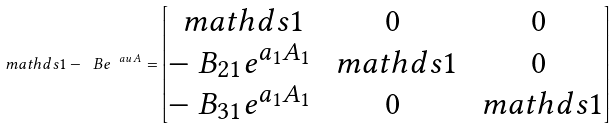<formula> <loc_0><loc_0><loc_500><loc_500>\ m a t h d s { 1 } - \ B e ^ { \ a u \, A } = \begin{bmatrix} \ m a t h d s { 1 } & 0 & 0 \\ - \ B _ { 2 1 } e ^ { a _ { 1 } A _ { 1 } } & \ m a t h d s { 1 } & 0 \\ - \ B _ { 3 1 } e ^ { a _ { 1 } A _ { 1 } } & 0 & \ m a t h d s { 1 } \\ \end{bmatrix}</formula> 